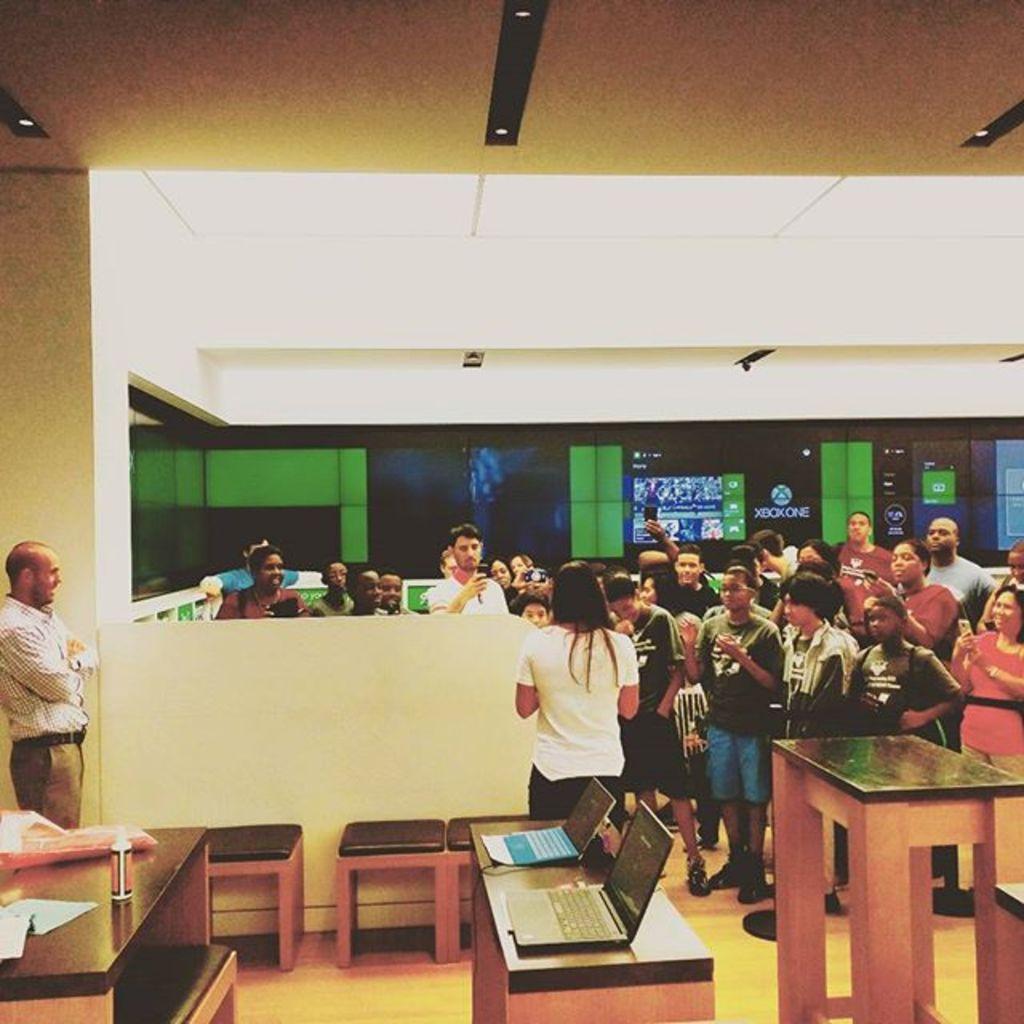How would you summarize this image in a sentence or two? here we can see a group of people are standing on the floor, and here is the table and laptops on it and some other objects on it, and her is the light. 